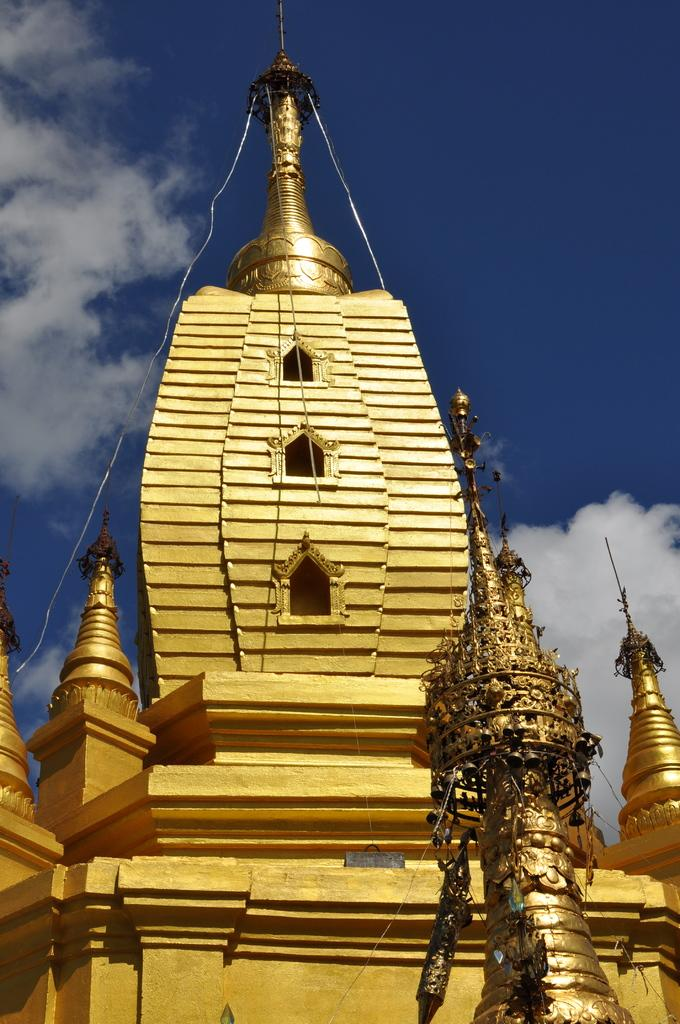What type of structure is present in the image? There is a temple in the image. What color is the temple painted? The temple is painted in golden color. What can be seen in the background of the image? The sky is visible in the background of the image. What is the condition of the sky in the image? There are clouds in the sky. What type of whip can be seen hanging from the temple in the image? There is no whip present in the image; it features a golden-colored temple with a visible sky and clouds. How many tomatoes are visible on the temple's roof in the image? There are no tomatoes present on the temple's roof in the image. 